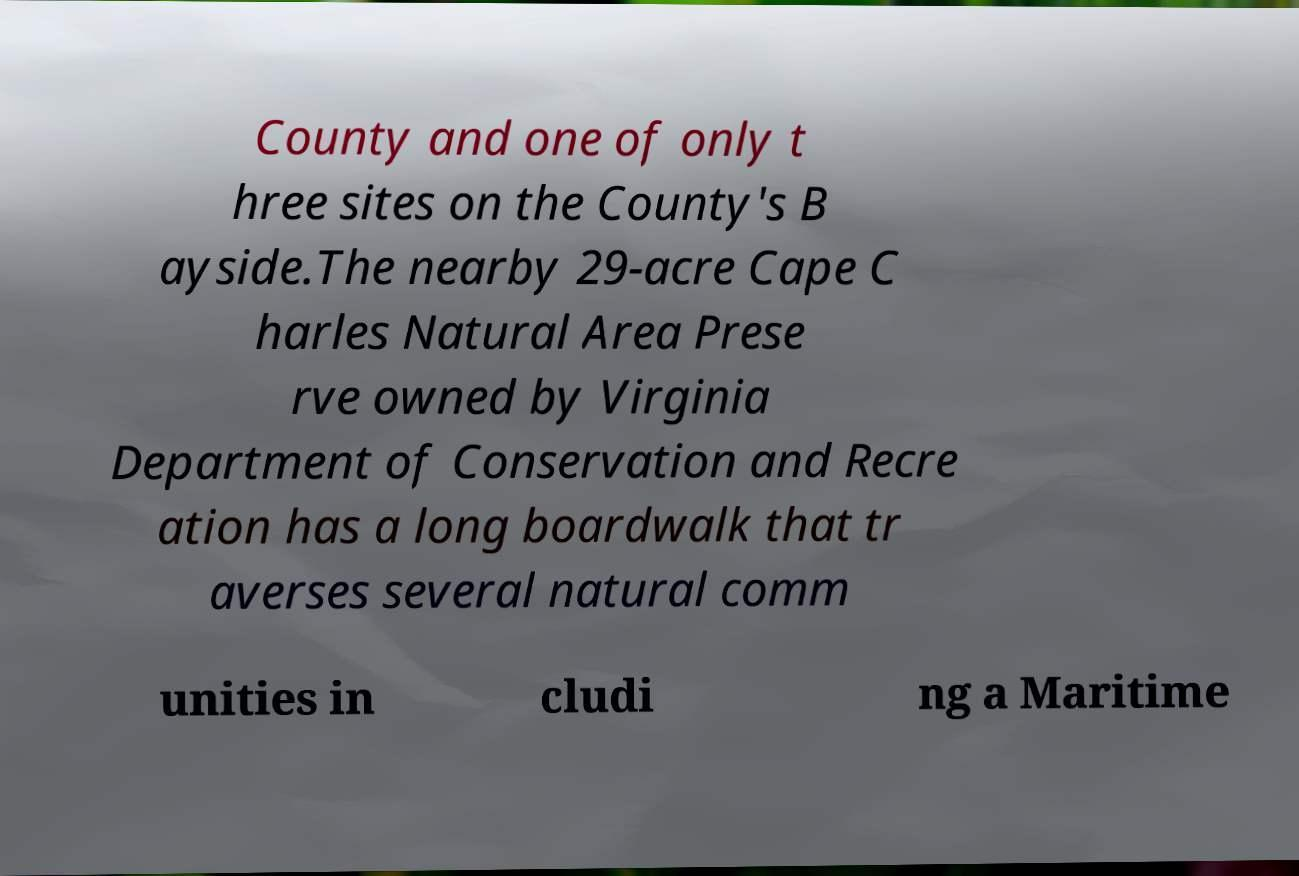Please read and relay the text visible in this image. What does it say? County and one of only t hree sites on the County's B ayside.The nearby 29-acre Cape C harles Natural Area Prese rve owned by Virginia Department of Conservation and Recre ation has a long boardwalk that tr averses several natural comm unities in cludi ng a Maritime 